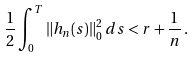Convert formula to latex. <formula><loc_0><loc_0><loc_500><loc_500>\frac { 1 } { 2 } \int _ { 0 } ^ { T } \| h _ { n } ( s ) \| _ { 0 } ^ { 2 } \, d s < r + \frac { 1 } { n } \, .</formula> 